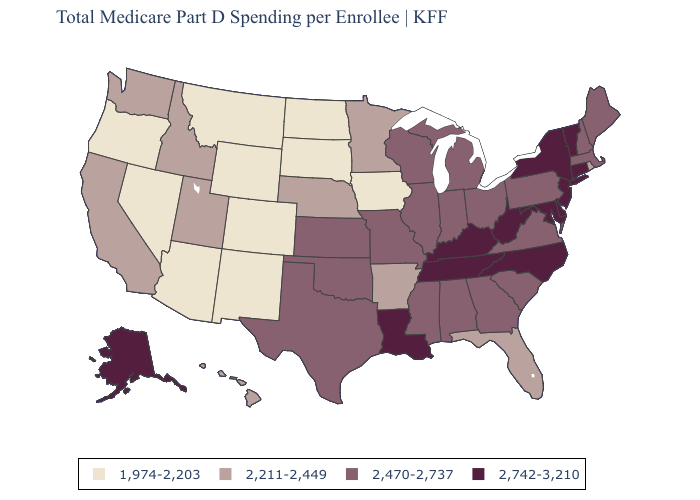What is the value of Tennessee?
Be succinct. 2,742-3,210. What is the value of Wisconsin?
Quick response, please. 2,470-2,737. Which states have the highest value in the USA?
Be succinct. Alaska, Connecticut, Delaware, Kentucky, Louisiana, Maryland, New Jersey, New York, North Carolina, Tennessee, Vermont, West Virginia. Which states hav the highest value in the South?
Give a very brief answer. Delaware, Kentucky, Louisiana, Maryland, North Carolina, Tennessee, West Virginia. Does Illinois have the highest value in the MidWest?
Write a very short answer. Yes. What is the value of Iowa?
Be succinct. 1,974-2,203. What is the highest value in the South ?
Concise answer only. 2,742-3,210. Does the first symbol in the legend represent the smallest category?
Be succinct. Yes. Name the states that have a value in the range 2,742-3,210?
Concise answer only. Alaska, Connecticut, Delaware, Kentucky, Louisiana, Maryland, New Jersey, New York, North Carolina, Tennessee, Vermont, West Virginia. Which states have the lowest value in the South?
Concise answer only. Arkansas, Florida. Does the map have missing data?
Concise answer only. No. What is the highest value in the MidWest ?
Short answer required. 2,470-2,737. Among the states that border Nebraska , does Kansas have the highest value?
Write a very short answer. Yes. Does Minnesota have the highest value in the MidWest?
Keep it brief. No. What is the lowest value in the USA?
Write a very short answer. 1,974-2,203. 